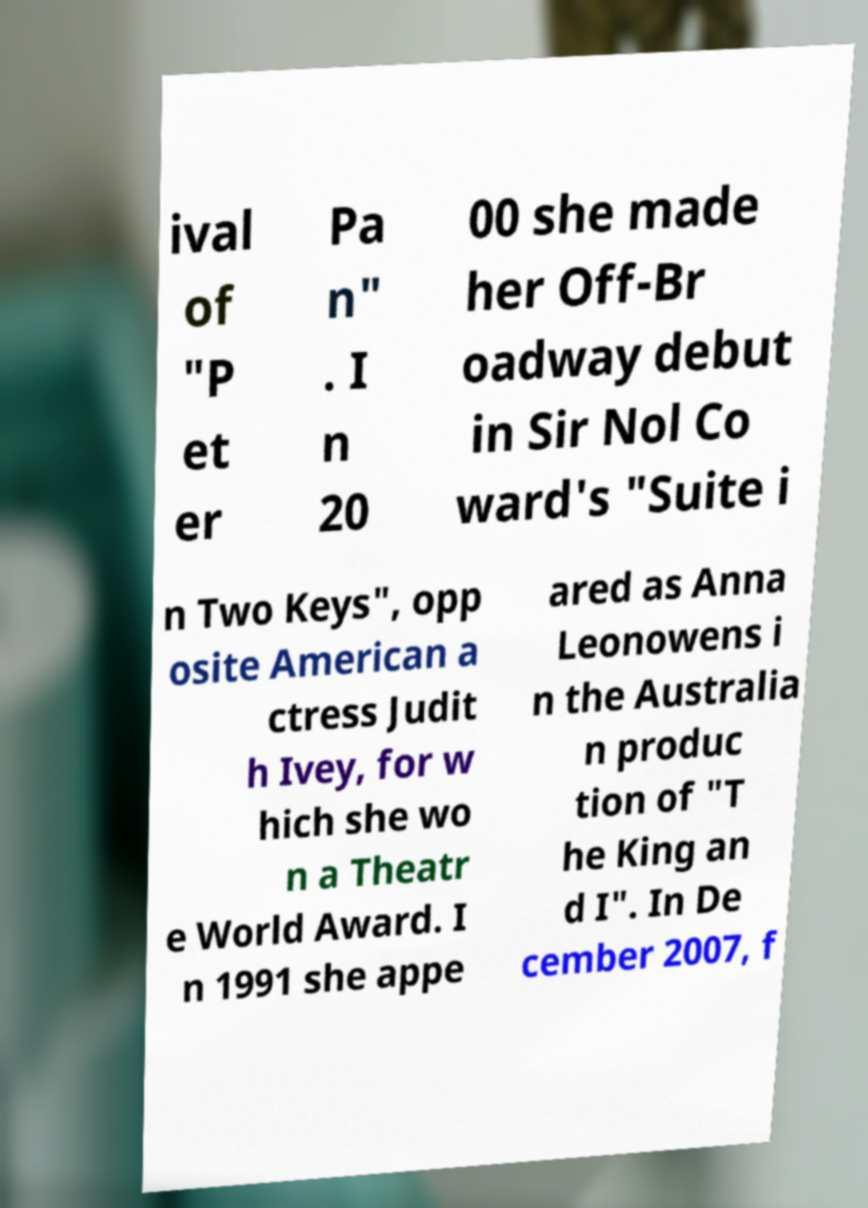Could you assist in decoding the text presented in this image and type it out clearly? ival of "P et er Pa n" . I n 20 00 she made her Off-Br oadway debut in Sir Nol Co ward's "Suite i n Two Keys", opp osite American a ctress Judit h Ivey, for w hich she wo n a Theatr e World Award. I n 1991 she appe ared as Anna Leonowens i n the Australia n produc tion of "T he King an d I". In De cember 2007, f 